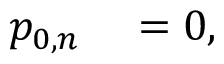<formula> <loc_0><loc_0><loc_500><loc_500>\begin{array} { r l } { p _ { 0 , n } } & = 0 , } \end{array}</formula> 